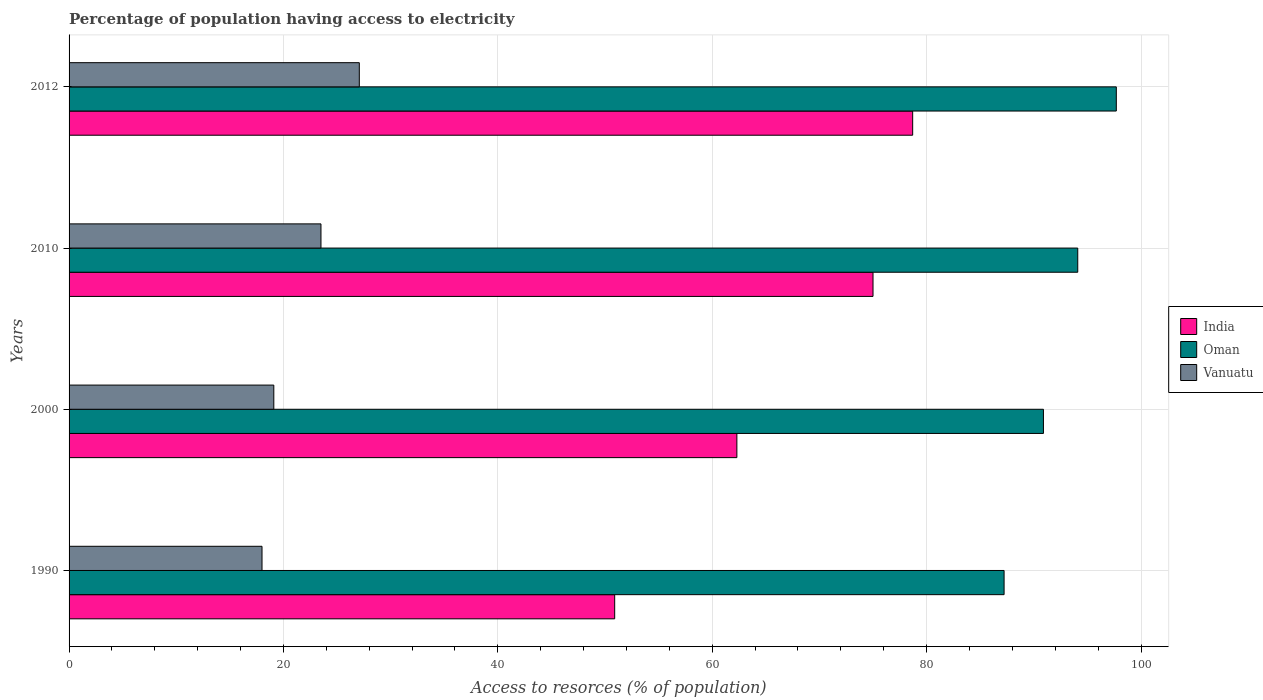How many different coloured bars are there?
Your response must be concise. 3. Are the number of bars per tick equal to the number of legend labels?
Your response must be concise. Yes. Are the number of bars on each tick of the Y-axis equal?
Ensure brevity in your answer.  Yes. How many bars are there on the 1st tick from the top?
Your answer should be compact. 3. What is the label of the 3rd group of bars from the top?
Offer a very short reply. 2000. What is the percentage of population having access to electricity in India in 2012?
Provide a short and direct response. 78.7. Across all years, what is the maximum percentage of population having access to electricity in India?
Provide a short and direct response. 78.7. Across all years, what is the minimum percentage of population having access to electricity in Vanuatu?
Your answer should be very brief. 18. In which year was the percentage of population having access to electricity in Oman maximum?
Your answer should be compact. 2012. What is the total percentage of population having access to electricity in Oman in the graph?
Keep it short and to the point. 369.92. What is the difference between the percentage of population having access to electricity in Oman in 1990 and that in 2012?
Ensure brevity in your answer.  -10.47. What is the difference between the percentage of population having access to electricity in Oman in 1990 and the percentage of population having access to electricity in Vanuatu in 2010?
Offer a very short reply. 63.73. What is the average percentage of population having access to electricity in India per year?
Make the answer very short. 66.72. In the year 1990, what is the difference between the percentage of population having access to electricity in Oman and percentage of population having access to electricity in Vanuatu?
Give a very brief answer. 69.23. In how many years, is the percentage of population having access to electricity in Oman greater than 68 %?
Your answer should be very brief. 4. What is the ratio of the percentage of population having access to electricity in India in 1990 to that in 2000?
Provide a short and direct response. 0.82. What is the difference between the highest and the second highest percentage of population having access to electricity in Vanuatu?
Ensure brevity in your answer.  3.58. What is the difference between the highest and the lowest percentage of population having access to electricity in India?
Give a very brief answer. 27.8. What does the 2nd bar from the top in 2000 represents?
Your answer should be compact. Oman. What does the 2nd bar from the bottom in 2010 represents?
Your answer should be compact. Oman. How many bars are there?
Keep it short and to the point. 12. Are all the bars in the graph horizontal?
Give a very brief answer. Yes. How many years are there in the graph?
Your response must be concise. 4. What is the difference between two consecutive major ticks on the X-axis?
Give a very brief answer. 20. Does the graph contain any zero values?
Make the answer very short. No. Does the graph contain grids?
Keep it short and to the point. Yes. Where does the legend appear in the graph?
Provide a succinct answer. Center right. How are the legend labels stacked?
Make the answer very short. Vertical. What is the title of the graph?
Your answer should be compact. Percentage of population having access to electricity. Does "Korea (Democratic)" appear as one of the legend labels in the graph?
Your response must be concise. No. What is the label or title of the X-axis?
Your answer should be very brief. Access to resorces (% of population). What is the Access to resorces (% of population) of India in 1990?
Offer a very short reply. 50.9. What is the Access to resorces (% of population) in Oman in 1990?
Your answer should be very brief. 87.23. What is the Access to resorces (% of population) in Vanuatu in 1990?
Keep it short and to the point. 18. What is the Access to resorces (% of population) in India in 2000?
Offer a very short reply. 62.3. What is the Access to resorces (% of population) in Oman in 2000?
Provide a succinct answer. 90.9. What is the Access to resorces (% of population) in India in 2010?
Make the answer very short. 75. What is the Access to resorces (% of population) of Oman in 2010?
Provide a succinct answer. 94.1. What is the Access to resorces (% of population) in India in 2012?
Give a very brief answer. 78.7. What is the Access to resorces (% of population) in Oman in 2012?
Make the answer very short. 97.7. What is the Access to resorces (% of population) in Vanuatu in 2012?
Offer a terse response. 27.08. Across all years, what is the maximum Access to resorces (% of population) of India?
Make the answer very short. 78.7. Across all years, what is the maximum Access to resorces (% of population) of Oman?
Your answer should be very brief. 97.7. Across all years, what is the maximum Access to resorces (% of population) of Vanuatu?
Your response must be concise. 27.08. Across all years, what is the minimum Access to resorces (% of population) in India?
Your response must be concise. 50.9. Across all years, what is the minimum Access to resorces (% of population) of Oman?
Give a very brief answer. 87.23. Across all years, what is the minimum Access to resorces (% of population) of Vanuatu?
Your answer should be compact. 18. What is the total Access to resorces (% of population) in India in the graph?
Provide a short and direct response. 266.9. What is the total Access to resorces (% of population) of Oman in the graph?
Ensure brevity in your answer.  369.92. What is the total Access to resorces (% of population) of Vanuatu in the graph?
Your response must be concise. 87.68. What is the difference between the Access to resorces (% of population) in Oman in 1990 and that in 2000?
Your answer should be very brief. -3.67. What is the difference between the Access to resorces (% of population) of Vanuatu in 1990 and that in 2000?
Your response must be concise. -1.1. What is the difference between the Access to resorces (% of population) in India in 1990 and that in 2010?
Give a very brief answer. -24.1. What is the difference between the Access to resorces (% of population) of Oman in 1990 and that in 2010?
Your answer should be very brief. -6.87. What is the difference between the Access to resorces (% of population) in India in 1990 and that in 2012?
Keep it short and to the point. -27.8. What is the difference between the Access to resorces (% of population) of Oman in 1990 and that in 2012?
Offer a very short reply. -10.47. What is the difference between the Access to resorces (% of population) of Vanuatu in 1990 and that in 2012?
Your response must be concise. -9.08. What is the difference between the Access to resorces (% of population) of India in 2000 and that in 2010?
Keep it short and to the point. -12.7. What is the difference between the Access to resorces (% of population) of Oman in 2000 and that in 2010?
Keep it short and to the point. -3.2. What is the difference between the Access to resorces (% of population) of India in 2000 and that in 2012?
Give a very brief answer. -16.4. What is the difference between the Access to resorces (% of population) in Oman in 2000 and that in 2012?
Ensure brevity in your answer.  -6.8. What is the difference between the Access to resorces (% of population) of Vanuatu in 2000 and that in 2012?
Provide a succinct answer. -7.98. What is the difference between the Access to resorces (% of population) of Oman in 2010 and that in 2012?
Your answer should be compact. -3.6. What is the difference between the Access to resorces (% of population) in Vanuatu in 2010 and that in 2012?
Your answer should be compact. -3.58. What is the difference between the Access to resorces (% of population) in India in 1990 and the Access to resorces (% of population) in Oman in 2000?
Provide a short and direct response. -40. What is the difference between the Access to resorces (% of population) of India in 1990 and the Access to resorces (% of population) of Vanuatu in 2000?
Give a very brief answer. 31.8. What is the difference between the Access to resorces (% of population) in Oman in 1990 and the Access to resorces (% of population) in Vanuatu in 2000?
Ensure brevity in your answer.  68.13. What is the difference between the Access to resorces (% of population) of India in 1990 and the Access to resorces (% of population) of Oman in 2010?
Your response must be concise. -43.2. What is the difference between the Access to resorces (% of population) of India in 1990 and the Access to resorces (% of population) of Vanuatu in 2010?
Ensure brevity in your answer.  27.4. What is the difference between the Access to resorces (% of population) of Oman in 1990 and the Access to resorces (% of population) of Vanuatu in 2010?
Your answer should be very brief. 63.73. What is the difference between the Access to resorces (% of population) of India in 1990 and the Access to resorces (% of population) of Oman in 2012?
Your response must be concise. -46.8. What is the difference between the Access to resorces (% of population) of India in 1990 and the Access to resorces (% of population) of Vanuatu in 2012?
Give a very brief answer. 23.82. What is the difference between the Access to resorces (% of population) of Oman in 1990 and the Access to resorces (% of population) of Vanuatu in 2012?
Keep it short and to the point. 60.15. What is the difference between the Access to resorces (% of population) in India in 2000 and the Access to resorces (% of population) in Oman in 2010?
Keep it short and to the point. -31.8. What is the difference between the Access to resorces (% of population) in India in 2000 and the Access to resorces (% of population) in Vanuatu in 2010?
Provide a succinct answer. 38.8. What is the difference between the Access to resorces (% of population) in Oman in 2000 and the Access to resorces (% of population) in Vanuatu in 2010?
Provide a succinct answer. 67.4. What is the difference between the Access to resorces (% of population) in India in 2000 and the Access to resorces (% of population) in Oman in 2012?
Make the answer very short. -35.4. What is the difference between the Access to resorces (% of population) in India in 2000 and the Access to resorces (% of population) in Vanuatu in 2012?
Your response must be concise. 35.22. What is the difference between the Access to resorces (% of population) in Oman in 2000 and the Access to resorces (% of population) in Vanuatu in 2012?
Keep it short and to the point. 63.82. What is the difference between the Access to resorces (% of population) in India in 2010 and the Access to resorces (% of population) in Oman in 2012?
Make the answer very short. -22.7. What is the difference between the Access to resorces (% of population) in India in 2010 and the Access to resorces (% of population) in Vanuatu in 2012?
Ensure brevity in your answer.  47.92. What is the difference between the Access to resorces (% of population) in Oman in 2010 and the Access to resorces (% of population) in Vanuatu in 2012?
Provide a succinct answer. 67.02. What is the average Access to resorces (% of population) of India per year?
Give a very brief answer. 66.72. What is the average Access to resorces (% of population) of Oman per year?
Give a very brief answer. 92.48. What is the average Access to resorces (% of population) in Vanuatu per year?
Give a very brief answer. 21.92. In the year 1990, what is the difference between the Access to resorces (% of population) in India and Access to resorces (% of population) in Oman?
Make the answer very short. -36.33. In the year 1990, what is the difference between the Access to resorces (% of population) of India and Access to resorces (% of population) of Vanuatu?
Provide a succinct answer. 32.9. In the year 1990, what is the difference between the Access to resorces (% of population) of Oman and Access to resorces (% of population) of Vanuatu?
Keep it short and to the point. 69.23. In the year 2000, what is the difference between the Access to resorces (% of population) in India and Access to resorces (% of population) in Oman?
Offer a terse response. -28.6. In the year 2000, what is the difference between the Access to resorces (% of population) in India and Access to resorces (% of population) in Vanuatu?
Provide a short and direct response. 43.2. In the year 2000, what is the difference between the Access to resorces (% of population) in Oman and Access to resorces (% of population) in Vanuatu?
Your answer should be very brief. 71.8. In the year 2010, what is the difference between the Access to resorces (% of population) of India and Access to resorces (% of population) of Oman?
Give a very brief answer. -19.1. In the year 2010, what is the difference between the Access to resorces (% of population) of India and Access to resorces (% of population) of Vanuatu?
Keep it short and to the point. 51.5. In the year 2010, what is the difference between the Access to resorces (% of population) in Oman and Access to resorces (% of population) in Vanuatu?
Your response must be concise. 70.6. In the year 2012, what is the difference between the Access to resorces (% of population) of India and Access to resorces (% of population) of Oman?
Make the answer very short. -19. In the year 2012, what is the difference between the Access to resorces (% of population) of India and Access to resorces (% of population) of Vanuatu?
Give a very brief answer. 51.62. In the year 2012, what is the difference between the Access to resorces (% of population) in Oman and Access to resorces (% of population) in Vanuatu?
Provide a short and direct response. 70.62. What is the ratio of the Access to resorces (% of population) in India in 1990 to that in 2000?
Offer a very short reply. 0.82. What is the ratio of the Access to resorces (% of population) in Oman in 1990 to that in 2000?
Provide a short and direct response. 0.96. What is the ratio of the Access to resorces (% of population) of Vanuatu in 1990 to that in 2000?
Provide a succinct answer. 0.94. What is the ratio of the Access to resorces (% of population) in India in 1990 to that in 2010?
Provide a succinct answer. 0.68. What is the ratio of the Access to resorces (% of population) of Oman in 1990 to that in 2010?
Make the answer very short. 0.93. What is the ratio of the Access to resorces (% of population) in Vanuatu in 1990 to that in 2010?
Provide a succinct answer. 0.77. What is the ratio of the Access to resorces (% of population) in India in 1990 to that in 2012?
Your response must be concise. 0.65. What is the ratio of the Access to resorces (% of population) of Oman in 1990 to that in 2012?
Your response must be concise. 0.89. What is the ratio of the Access to resorces (% of population) of Vanuatu in 1990 to that in 2012?
Your answer should be compact. 0.66. What is the ratio of the Access to resorces (% of population) in India in 2000 to that in 2010?
Provide a short and direct response. 0.83. What is the ratio of the Access to resorces (% of population) of Vanuatu in 2000 to that in 2010?
Give a very brief answer. 0.81. What is the ratio of the Access to resorces (% of population) of India in 2000 to that in 2012?
Offer a terse response. 0.79. What is the ratio of the Access to resorces (% of population) of Oman in 2000 to that in 2012?
Offer a terse response. 0.93. What is the ratio of the Access to resorces (% of population) of Vanuatu in 2000 to that in 2012?
Make the answer very short. 0.71. What is the ratio of the Access to resorces (% of population) of India in 2010 to that in 2012?
Offer a very short reply. 0.95. What is the ratio of the Access to resorces (% of population) in Oman in 2010 to that in 2012?
Offer a very short reply. 0.96. What is the ratio of the Access to resorces (% of population) in Vanuatu in 2010 to that in 2012?
Provide a short and direct response. 0.87. What is the difference between the highest and the second highest Access to resorces (% of population) of India?
Your answer should be very brief. 3.7. What is the difference between the highest and the second highest Access to resorces (% of population) of Oman?
Provide a succinct answer. 3.6. What is the difference between the highest and the second highest Access to resorces (% of population) of Vanuatu?
Give a very brief answer. 3.58. What is the difference between the highest and the lowest Access to resorces (% of population) in India?
Ensure brevity in your answer.  27.8. What is the difference between the highest and the lowest Access to resorces (% of population) of Oman?
Provide a short and direct response. 10.47. What is the difference between the highest and the lowest Access to resorces (% of population) of Vanuatu?
Offer a terse response. 9.08. 